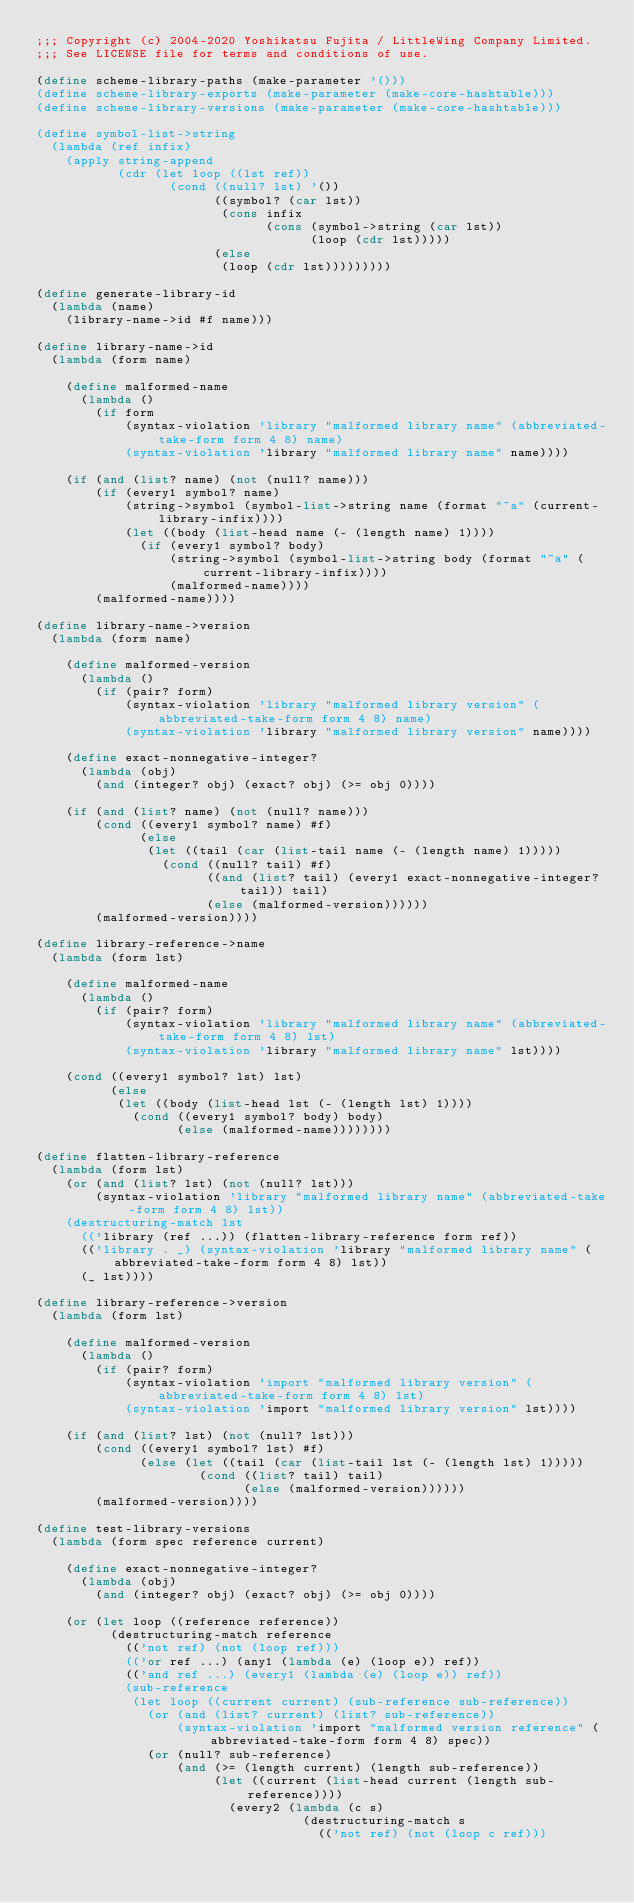Convert code to text. <code><loc_0><loc_0><loc_500><loc_500><_Scheme_>;;; Copyright (c) 2004-2020 Yoshikatsu Fujita / LittleWing Company Limited.
;;; See LICENSE file for terms and conditions of use.

(define scheme-library-paths (make-parameter '()))
(define scheme-library-exports (make-parameter (make-core-hashtable)))
(define scheme-library-versions (make-parameter (make-core-hashtable)))

(define symbol-list->string
  (lambda (ref infix)
    (apply string-append
           (cdr (let loop ((lst ref))
                  (cond ((null? lst) '())
                        ((symbol? (car lst))
                         (cons infix
                               (cons (symbol->string (car lst))
                                     (loop (cdr lst)))))
                        (else
                         (loop (cdr lst)))))))))

(define generate-library-id
  (lambda (name)
    (library-name->id #f name)))

(define library-name->id
  (lambda (form name)

    (define malformed-name
      (lambda ()
        (if form
            (syntax-violation 'library "malformed library name" (abbreviated-take-form form 4 8) name)
            (syntax-violation 'library "malformed library name" name))))

    (if (and (list? name) (not (null? name)))
        (if (every1 symbol? name)
            (string->symbol (symbol-list->string name (format "~a" (current-library-infix))))
            (let ((body (list-head name (- (length name) 1))))
              (if (every1 symbol? body)
                  (string->symbol (symbol-list->string body (format "~a" (current-library-infix))))
                  (malformed-name))))
        (malformed-name))))

(define library-name->version
  (lambda (form name)

    (define malformed-version
      (lambda ()
        (if (pair? form)
            (syntax-violation 'library "malformed library version" (abbreviated-take-form form 4 8) name)
            (syntax-violation 'library "malformed library version" name))))

    (define exact-nonnegative-integer?
      (lambda (obj)
        (and (integer? obj) (exact? obj) (>= obj 0))))

    (if (and (list? name) (not (null? name)))
        (cond ((every1 symbol? name) #f)
              (else
               (let ((tail (car (list-tail name (- (length name) 1)))))
                 (cond ((null? tail) #f)
                       ((and (list? tail) (every1 exact-nonnegative-integer? tail)) tail)
                       (else (malformed-version))))))
        (malformed-version))))

(define library-reference->name
  (lambda (form lst)

    (define malformed-name
      (lambda ()
        (if (pair? form)
            (syntax-violation 'library "malformed library name" (abbreviated-take-form form 4 8) lst)
            (syntax-violation 'library "malformed library name" lst))))

    (cond ((every1 symbol? lst) lst)
          (else
           (let ((body (list-head lst (- (length lst) 1))))
             (cond ((every1 symbol? body) body)
                   (else (malformed-name))))))))

(define flatten-library-reference
  (lambda (form lst)
    (or (and (list? lst) (not (null? lst)))
        (syntax-violation 'library "malformed library name" (abbreviated-take-form form 4 8) lst))
    (destructuring-match lst
      (('library (ref ...)) (flatten-library-reference form ref))
      (('library . _) (syntax-violation 'library "malformed library name" (abbreviated-take-form form 4 8) lst))
      (_ lst))))

(define library-reference->version
  (lambda (form lst)

    (define malformed-version
      (lambda ()
        (if (pair? form)
            (syntax-violation 'import "malformed library version" (abbreviated-take-form form 4 8) lst)
            (syntax-violation 'import "malformed library version" lst))))

    (if (and (list? lst) (not (null? lst)))
        (cond ((every1 symbol? lst) #f)
              (else (let ((tail (car (list-tail lst (- (length lst) 1)))))
                      (cond ((list? tail) tail)
                            (else (malformed-version))))))
        (malformed-version))))

(define test-library-versions
  (lambda (form spec reference current)

    (define exact-nonnegative-integer?
      (lambda (obj)
        (and (integer? obj) (exact? obj) (>= obj 0))))

    (or (let loop ((reference reference))
          (destructuring-match reference
            (('not ref) (not (loop ref)))
            (('or ref ...) (any1 (lambda (e) (loop e)) ref))
            (('and ref ...) (every1 (lambda (e) (loop e)) ref))
            (sub-reference
             (let loop ((current current) (sub-reference sub-reference))
               (or (and (list? current) (list? sub-reference))
                   (syntax-violation 'import "malformed version reference" (abbreviated-take-form form 4 8) spec))
               (or (null? sub-reference)
                   (and (>= (length current) (length sub-reference))
                        (let ((current (list-head current (length sub-reference))))
                          (every2 (lambda (c s)
                                    (destructuring-match s
                                      (('not ref) (not (loop c ref)))</code> 